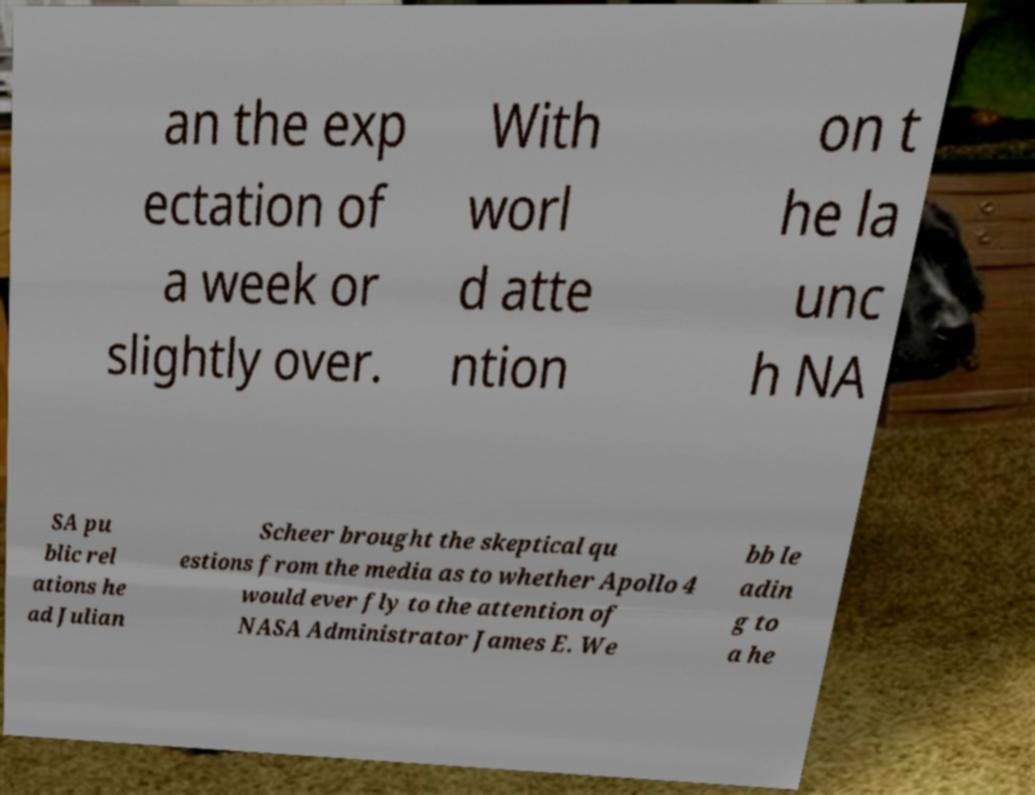Could you assist in decoding the text presented in this image and type it out clearly? an the exp ectation of a week or slightly over. With worl d atte ntion on t he la unc h NA SA pu blic rel ations he ad Julian Scheer brought the skeptical qu estions from the media as to whether Apollo 4 would ever fly to the attention of NASA Administrator James E. We bb le adin g to a he 